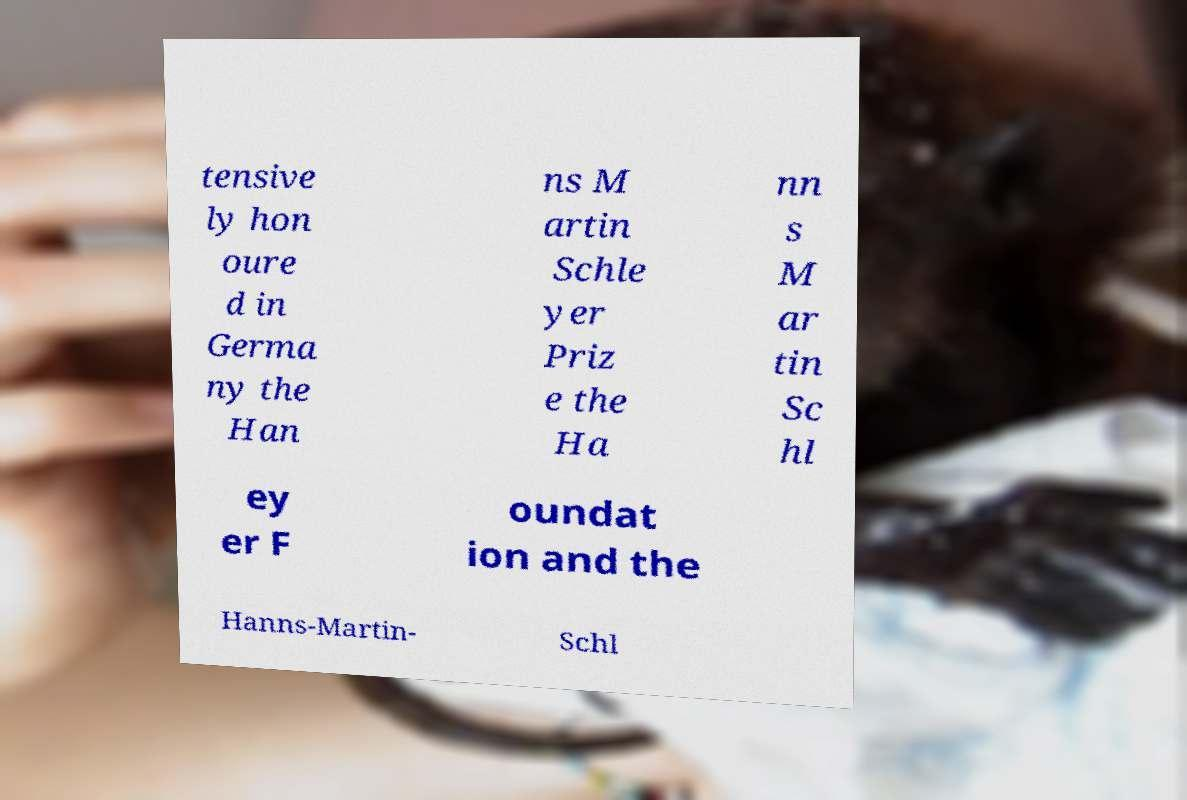There's text embedded in this image that I need extracted. Can you transcribe it verbatim? tensive ly hon oure d in Germa ny the Han ns M artin Schle yer Priz e the Ha nn s M ar tin Sc hl ey er F oundat ion and the Hanns-Martin- Schl 